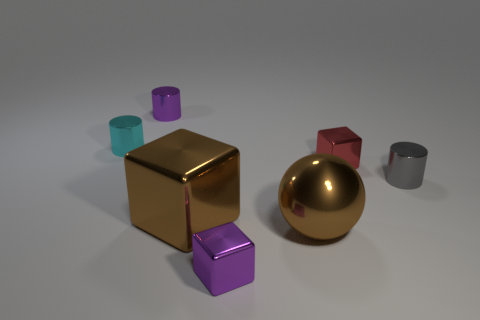Subtract all small red blocks. How many blocks are left? 2 Subtract all cylinders. How many objects are left? 4 Subtract 2 cylinders. How many cylinders are left? 1 Add 1 small cubes. How many objects exist? 8 Subtract all cyan cylinders. How many cylinders are left? 2 Subtract all cyan cubes. How many gray cylinders are left? 1 Subtract all tiny cyan cylinders. Subtract all brown balls. How many objects are left? 5 Add 4 brown objects. How many brown objects are left? 6 Add 4 blue metal spheres. How many blue metal spheres exist? 4 Subtract 0 gray blocks. How many objects are left? 7 